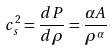<formula> <loc_0><loc_0><loc_500><loc_500>c _ { s } ^ { 2 } = \frac { d P } { d \rho } = \frac { \alpha A } { \rho ^ { \alpha } }</formula> 